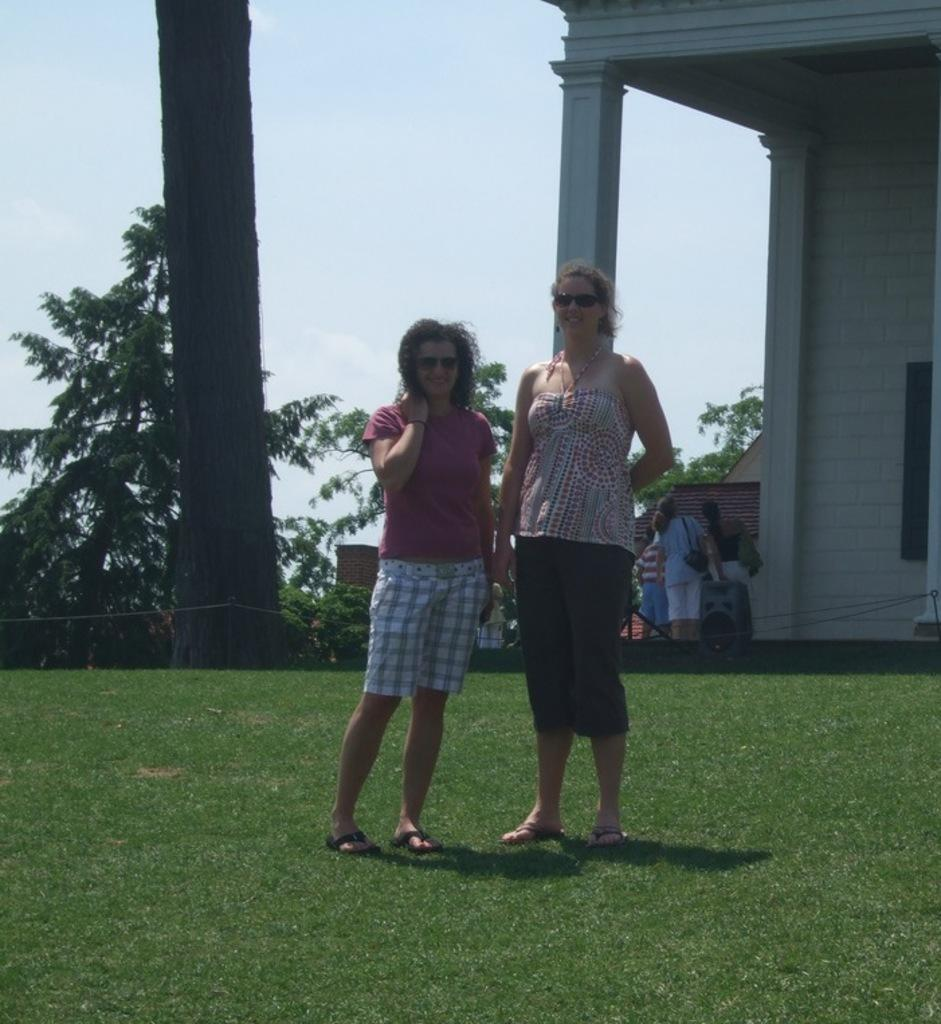How many people are in the image? There are people in the image, but the exact number is not specified. What type of ground is visible in the image? The ground with grass is visible in the image. What type of vegetation can be seen in the image? There are trees and plants in the image. What type of structure is present in the image? There is a house in the image. What architectural feature can be seen in the image? There is a pillar in the image. What part of the natural environment is visible in the image? The sky is visible in the image. How does the tub fit into the image? There is no tub present in the image. Can you describe the visitor in the image? There is no mention of a visitor in the image or the provided facts. 